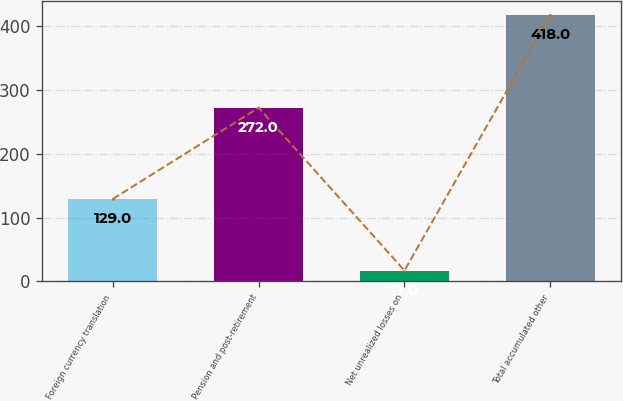Convert chart to OTSL. <chart><loc_0><loc_0><loc_500><loc_500><bar_chart><fcel>Foreign currency translation<fcel>Pension and post-retirement<fcel>Net unrealized losses on<fcel>Total accumulated other<nl><fcel>129<fcel>272<fcel>17<fcel>418<nl></chart> 